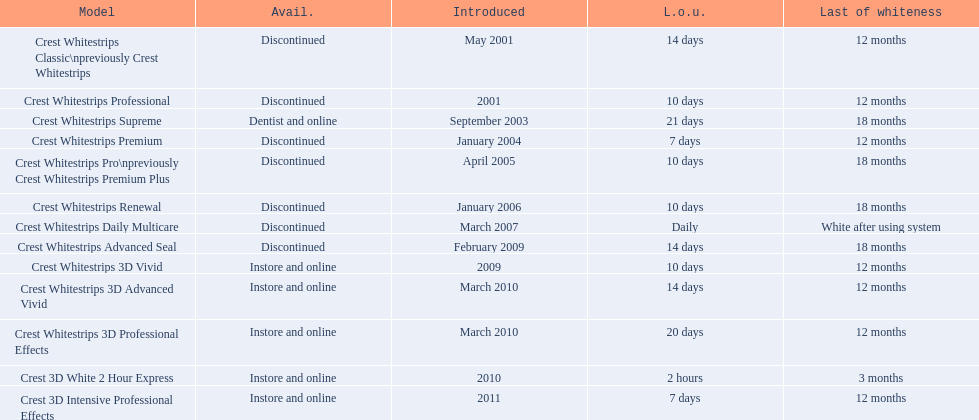What are all of the model names? Crest Whitestrips Classic\npreviously Crest Whitestrips, Crest Whitestrips Professional, Crest Whitestrips Supreme, Crest Whitestrips Premium, Crest Whitestrips Pro\npreviously Crest Whitestrips Premium Plus, Crest Whitestrips Renewal, Crest Whitestrips Daily Multicare, Crest Whitestrips Advanced Seal, Crest Whitestrips 3D Vivid, Crest Whitestrips 3D Advanced Vivid, Crest Whitestrips 3D Professional Effects, Crest 3D White 2 Hour Express, Crest 3D Intensive Professional Effects. When were they first introduced? May 2001, 2001, September 2003, January 2004, April 2005, January 2006, March 2007, February 2009, 2009, March 2010, March 2010, 2010, 2011. Along with crest whitestrips 3d advanced vivid, which other model was introduced in march 2010? Crest Whitestrips 3D Professional Effects. 